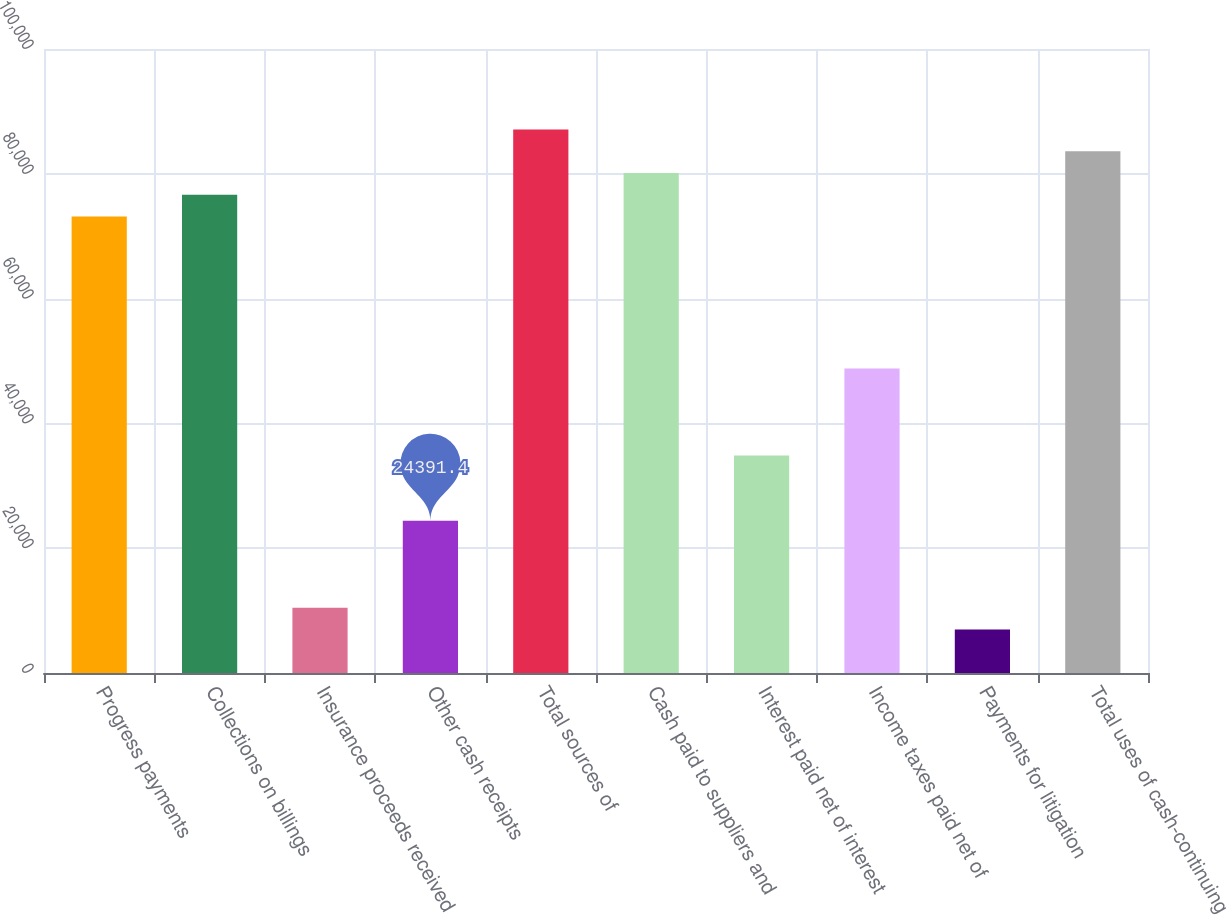<chart> <loc_0><loc_0><loc_500><loc_500><bar_chart><fcel>Progress payments<fcel>Collections on billings<fcel>Insurance proceeds received<fcel>Other cash receipts<fcel>Total sources of<fcel>Cash paid to suppliers and<fcel>Interest paid net of interest<fcel>Income taxes paid net of<fcel>Payments for litigation<fcel>Total uses of cash-continuing<nl><fcel>73170.2<fcel>76654.4<fcel>10454.6<fcel>24391.4<fcel>87107<fcel>80138.6<fcel>34844<fcel>48780.8<fcel>6970.4<fcel>83622.8<nl></chart> 